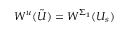<formula> <loc_0><loc_0><loc_500><loc_500>W ^ { u } ( \tilde { U } ) = W ^ { \Sigma _ { 1 } } ( U _ { s } )</formula> 